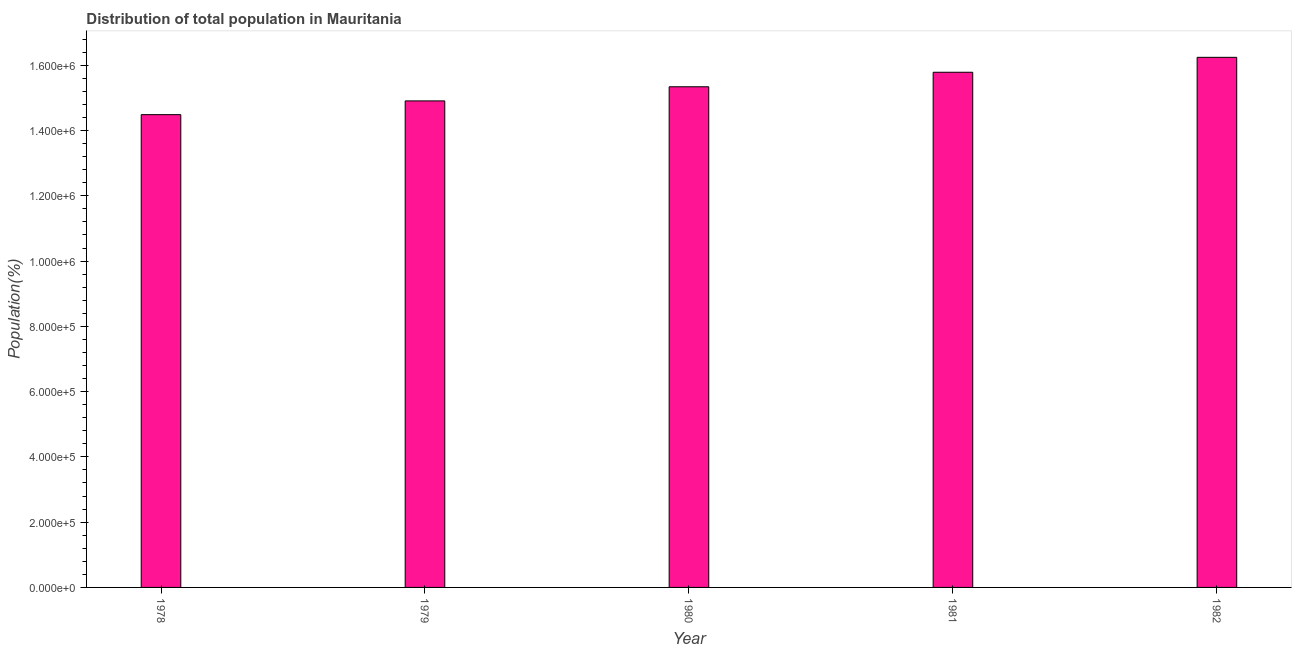Does the graph contain grids?
Provide a short and direct response. No. What is the title of the graph?
Give a very brief answer. Distribution of total population in Mauritania . What is the label or title of the X-axis?
Offer a terse response. Year. What is the label or title of the Y-axis?
Provide a short and direct response. Population(%). What is the population in 1979?
Offer a terse response. 1.49e+06. Across all years, what is the maximum population?
Your answer should be very brief. 1.62e+06. Across all years, what is the minimum population?
Your answer should be compact. 1.45e+06. In which year was the population maximum?
Offer a very short reply. 1982. In which year was the population minimum?
Provide a succinct answer. 1978. What is the sum of the population?
Offer a very short reply. 7.68e+06. What is the difference between the population in 1978 and 1982?
Make the answer very short. -1.76e+05. What is the average population per year?
Give a very brief answer. 1.54e+06. What is the median population?
Make the answer very short. 1.53e+06. What is the ratio of the population in 1978 to that in 1982?
Make the answer very short. 0.89. Is the population in 1980 less than that in 1981?
Your answer should be compact. Yes. What is the difference between the highest and the second highest population?
Provide a short and direct response. 4.57e+04. Is the sum of the population in 1978 and 1980 greater than the maximum population across all years?
Your answer should be very brief. Yes. What is the difference between the highest and the lowest population?
Ensure brevity in your answer.  1.76e+05. In how many years, is the population greater than the average population taken over all years?
Offer a terse response. 2. Are all the bars in the graph horizontal?
Give a very brief answer. No. Are the values on the major ticks of Y-axis written in scientific E-notation?
Ensure brevity in your answer.  Yes. What is the Population(%) in 1978?
Your answer should be very brief. 1.45e+06. What is the Population(%) in 1979?
Keep it short and to the point. 1.49e+06. What is the Population(%) of 1980?
Provide a short and direct response. 1.53e+06. What is the Population(%) in 1981?
Provide a succinct answer. 1.58e+06. What is the Population(%) of 1982?
Offer a terse response. 1.62e+06. What is the difference between the Population(%) in 1978 and 1979?
Offer a terse response. -4.21e+04. What is the difference between the Population(%) in 1978 and 1980?
Offer a terse response. -8.54e+04. What is the difference between the Population(%) in 1978 and 1981?
Provide a short and direct response. -1.30e+05. What is the difference between the Population(%) in 1978 and 1982?
Offer a very short reply. -1.76e+05. What is the difference between the Population(%) in 1979 and 1980?
Ensure brevity in your answer.  -4.33e+04. What is the difference between the Population(%) in 1979 and 1981?
Your response must be concise. -8.78e+04. What is the difference between the Population(%) in 1979 and 1982?
Your answer should be compact. -1.33e+05. What is the difference between the Population(%) in 1980 and 1981?
Your response must be concise. -4.45e+04. What is the difference between the Population(%) in 1980 and 1982?
Give a very brief answer. -9.02e+04. What is the difference between the Population(%) in 1981 and 1982?
Offer a terse response. -4.57e+04. What is the ratio of the Population(%) in 1978 to that in 1980?
Offer a very short reply. 0.94. What is the ratio of the Population(%) in 1978 to that in 1981?
Your answer should be very brief. 0.92. What is the ratio of the Population(%) in 1978 to that in 1982?
Ensure brevity in your answer.  0.89. What is the ratio of the Population(%) in 1979 to that in 1980?
Give a very brief answer. 0.97. What is the ratio of the Population(%) in 1979 to that in 1981?
Offer a terse response. 0.94. What is the ratio of the Population(%) in 1979 to that in 1982?
Give a very brief answer. 0.92. What is the ratio of the Population(%) in 1980 to that in 1981?
Ensure brevity in your answer.  0.97. What is the ratio of the Population(%) in 1980 to that in 1982?
Give a very brief answer. 0.94. What is the ratio of the Population(%) in 1981 to that in 1982?
Give a very brief answer. 0.97. 